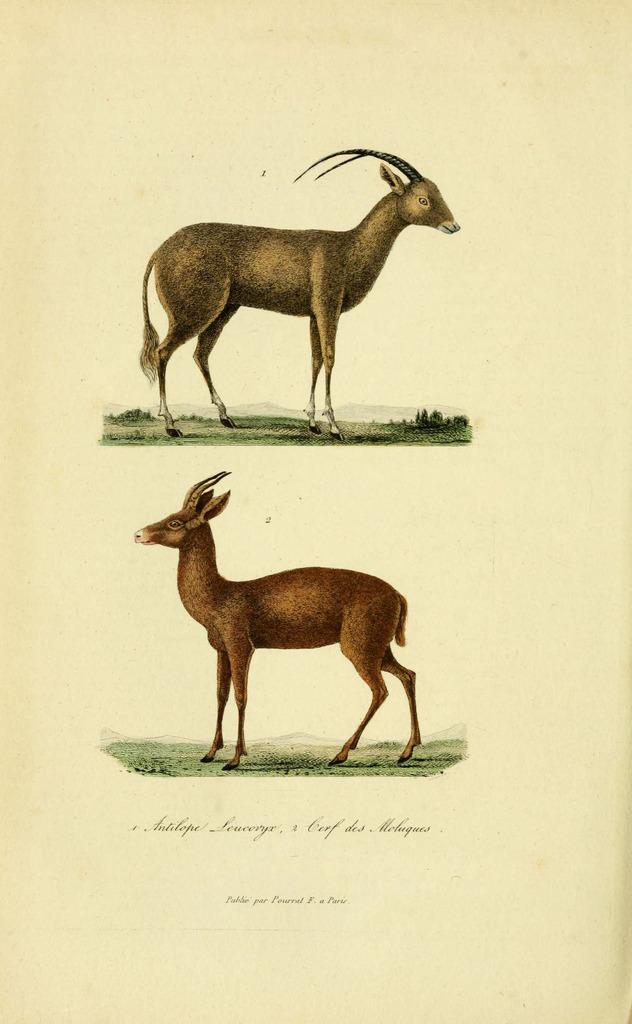What is present on the paper in the image? There is text in the image. How many animals can be seen in the image? There are two animals in the image. What type of vegetation is visible in the image? There is grass and plants in the image. What is the color of the background in the image? The background of the image is white in color. Can you tell me how many horses are jumping in the image? There are no horses or jumping depicted in the image. How many pages are visible in the image? There is no reference to a page or pages in the image; it features a paper with text. 